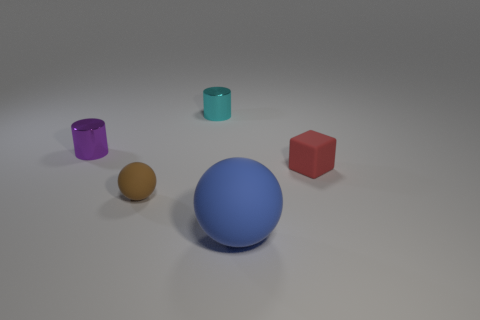Add 2 tiny red cubes. How many objects exist? 7 Add 4 cyan matte objects. How many cyan matte objects exist? 4 Subtract 0 purple balls. How many objects are left? 5 Subtract all balls. How many objects are left? 3 Subtract all purple shiny cylinders. Subtract all small metallic cylinders. How many objects are left? 2 Add 2 small red blocks. How many small red blocks are left? 3 